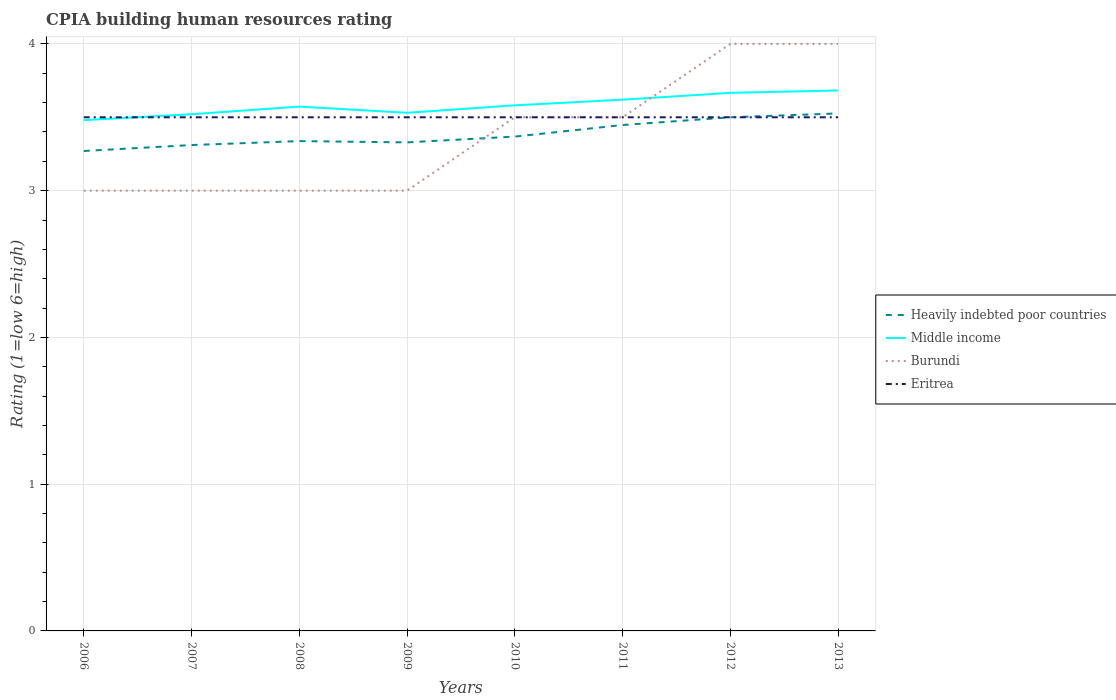In which year was the CPIA rating in Middle income maximum?
Offer a terse response. 2006. What is the difference between two consecutive major ticks on the Y-axis?
Give a very brief answer. 1. Are the values on the major ticks of Y-axis written in scientific E-notation?
Make the answer very short. No. How many legend labels are there?
Give a very brief answer. 4. How are the legend labels stacked?
Ensure brevity in your answer.  Vertical. What is the title of the graph?
Offer a very short reply. CPIA building human resources rating. Does "Turks and Caicos Islands" appear as one of the legend labels in the graph?
Provide a succinct answer. No. What is the label or title of the X-axis?
Provide a short and direct response. Years. What is the Rating (1=low 6=high) in Heavily indebted poor countries in 2006?
Provide a short and direct response. 3.27. What is the Rating (1=low 6=high) in Middle income in 2006?
Keep it short and to the point. 3.48. What is the Rating (1=low 6=high) in Eritrea in 2006?
Provide a short and direct response. 3.5. What is the Rating (1=low 6=high) in Heavily indebted poor countries in 2007?
Your response must be concise. 3.31. What is the Rating (1=low 6=high) of Middle income in 2007?
Provide a short and direct response. 3.52. What is the Rating (1=low 6=high) in Eritrea in 2007?
Provide a succinct answer. 3.5. What is the Rating (1=low 6=high) of Heavily indebted poor countries in 2008?
Keep it short and to the point. 3.34. What is the Rating (1=low 6=high) of Middle income in 2008?
Your response must be concise. 3.57. What is the Rating (1=low 6=high) in Eritrea in 2008?
Make the answer very short. 3.5. What is the Rating (1=low 6=high) in Heavily indebted poor countries in 2009?
Give a very brief answer. 3.33. What is the Rating (1=low 6=high) of Middle income in 2009?
Your answer should be very brief. 3.53. What is the Rating (1=low 6=high) of Eritrea in 2009?
Ensure brevity in your answer.  3.5. What is the Rating (1=low 6=high) of Heavily indebted poor countries in 2010?
Make the answer very short. 3.37. What is the Rating (1=low 6=high) in Middle income in 2010?
Offer a terse response. 3.58. What is the Rating (1=low 6=high) in Heavily indebted poor countries in 2011?
Provide a succinct answer. 3.45. What is the Rating (1=low 6=high) of Middle income in 2011?
Give a very brief answer. 3.62. What is the Rating (1=low 6=high) of Burundi in 2011?
Offer a terse response. 3.5. What is the Rating (1=low 6=high) of Eritrea in 2011?
Your response must be concise. 3.5. What is the Rating (1=low 6=high) of Heavily indebted poor countries in 2012?
Your response must be concise. 3.5. What is the Rating (1=low 6=high) in Middle income in 2012?
Provide a short and direct response. 3.67. What is the Rating (1=low 6=high) in Burundi in 2012?
Provide a succinct answer. 4. What is the Rating (1=low 6=high) in Eritrea in 2012?
Keep it short and to the point. 3.5. What is the Rating (1=low 6=high) in Heavily indebted poor countries in 2013?
Give a very brief answer. 3.53. What is the Rating (1=low 6=high) in Middle income in 2013?
Offer a terse response. 3.68. What is the Rating (1=low 6=high) of Burundi in 2013?
Provide a short and direct response. 4. Across all years, what is the maximum Rating (1=low 6=high) of Heavily indebted poor countries?
Your answer should be compact. 3.53. Across all years, what is the maximum Rating (1=low 6=high) of Middle income?
Your response must be concise. 3.68. Across all years, what is the maximum Rating (1=low 6=high) of Eritrea?
Provide a short and direct response. 3.5. Across all years, what is the minimum Rating (1=low 6=high) in Heavily indebted poor countries?
Offer a terse response. 3.27. Across all years, what is the minimum Rating (1=low 6=high) of Middle income?
Give a very brief answer. 3.48. Across all years, what is the minimum Rating (1=low 6=high) in Burundi?
Provide a succinct answer. 3. Across all years, what is the minimum Rating (1=low 6=high) in Eritrea?
Make the answer very short. 3.5. What is the total Rating (1=low 6=high) of Heavily indebted poor countries in the graph?
Ensure brevity in your answer.  27.09. What is the total Rating (1=low 6=high) in Middle income in the graph?
Keep it short and to the point. 28.66. What is the difference between the Rating (1=low 6=high) in Heavily indebted poor countries in 2006 and that in 2007?
Provide a short and direct response. -0.04. What is the difference between the Rating (1=low 6=high) of Middle income in 2006 and that in 2007?
Offer a very short reply. -0.04. What is the difference between the Rating (1=low 6=high) of Eritrea in 2006 and that in 2007?
Keep it short and to the point. 0. What is the difference between the Rating (1=low 6=high) in Heavily indebted poor countries in 2006 and that in 2008?
Your answer should be compact. -0.07. What is the difference between the Rating (1=low 6=high) of Middle income in 2006 and that in 2008?
Your answer should be very brief. -0.09. What is the difference between the Rating (1=low 6=high) of Heavily indebted poor countries in 2006 and that in 2009?
Offer a terse response. -0.06. What is the difference between the Rating (1=low 6=high) in Middle income in 2006 and that in 2009?
Ensure brevity in your answer.  -0.05. What is the difference between the Rating (1=low 6=high) in Eritrea in 2006 and that in 2009?
Make the answer very short. 0. What is the difference between the Rating (1=low 6=high) of Heavily indebted poor countries in 2006 and that in 2010?
Your response must be concise. -0.1. What is the difference between the Rating (1=low 6=high) in Middle income in 2006 and that in 2010?
Your response must be concise. -0.1. What is the difference between the Rating (1=low 6=high) of Burundi in 2006 and that in 2010?
Your response must be concise. -0.5. What is the difference between the Rating (1=low 6=high) of Eritrea in 2006 and that in 2010?
Your answer should be compact. 0. What is the difference between the Rating (1=low 6=high) of Heavily indebted poor countries in 2006 and that in 2011?
Offer a very short reply. -0.18. What is the difference between the Rating (1=low 6=high) of Middle income in 2006 and that in 2011?
Your response must be concise. -0.14. What is the difference between the Rating (1=low 6=high) in Eritrea in 2006 and that in 2011?
Your answer should be very brief. 0. What is the difference between the Rating (1=low 6=high) in Heavily indebted poor countries in 2006 and that in 2012?
Ensure brevity in your answer.  -0.23. What is the difference between the Rating (1=low 6=high) in Middle income in 2006 and that in 2012?
Ensure brevity in your answer.  -0.19. What is the difference between the Rating (1=low 6=high) of Heavily indebted poor countries in 2006 and that in 2013?
Offer a very short reply. -0.26. What is the difference between the Rating (1=low 6=high) of Middle income in 2006 and that in 2013?
Make the answer very short. -0.2. What is the difference between the Rating (1=low 6=high) in Burundi in 2006 and that in 2013?
Your answer should be very brief. -1. What is the difference between the Rating (1=low 6=high) of Heavily indebted poor countries in 2007 and that in 2008?
Offer a very short reply. -0.03. What is the difference between the Rating (1=low 6=high) of Middle income in 2007 and that in 2008?
Your answer should be very brief. -0.05. What is the difference between the Rating (1=low 6=high) in Eritrea in 2007 and that in 2008?
Give a very brief answer. 0. What is the difference between the Rating (1=low 6=high) of Heavily indebted poor countries in 2007 and that in 2009?
Offer a very short reply. -0.02. What is the difference between the Rating (1=low 6=high) of Middle income in 2007 and that in 2009?
Make the answer very short. -0.01. What is the difference between the Rating (1=low 6=high) in Heavily indebted poor countries in 2007 and that in 2010?
Your answer should be very brief. -0.06. What is the difference between the Rating (1=low 6=high) in Middle income in 2007 and that in 2010?
Give a very brief answer. -0.06. What is the difference between the Rating (1=low 6=high) of Heavily indebted poor countries in 2007 and that in 2011?
Ensure brevity in your answer.  -0.14. What is the difference between the Rating (1=low 6=high) of Middle income in 2007 and that in 2011?
Ensure brevity in your answer.  -0.1. What is the difference between the Rating (1=low 6=high) in Burundi in 2007 and that in 2011?
Keep it short and to the point. -0.5. What is the difference between the Rating (1=low 6=high) in Eritrea in 2007 and that in 2011?
Provide a short and direct response. 0. What is the difference between the Rating (1=low 6=high) in Heavily indebted poor countries in 2007 and that in 2012?
Provide a succinct answer. -0.19. What is the difference between the Rating (1=low 6=high) in Middle income in 2007 and that in 2012?
Give a very brief answer. -0.15. What is the difference between the Rating (1=low 6=high) of Heavily indebted poor countries in 2007 and that in 2013?
Ensure brevity in your answer.  -0.22. What is the difference between the Rating (1=low 6=high) of Middle income in 2007 and that in 2013?
Your answer should be very brief. -0.16. What is the difference between the Rating (1=low 6=high) of Heavily indebted poor countries in 2008 and that in 2009?
Give a very brief answer. 0.01. What is the difference between the Rating (1=low 6=high) in Middle income in 2008 and that in 2009?
Offer a very short reply. 0.04. What is the difference between the Rating (1=low 6=high) of Burundi in 2008 and that in 2009?
Offer a terse response. 0. What is the difference between the Rating (1=low 6=high) in Eritrea in 2008 and that in 2009?
Keep it short and to the point. 0. What is the difference between the Rating (1=low 6=high) in Heavily indebted poor countries in 2008 and that in 2010?
Your response must be concise. -0.03. What is the difference between the Rating (1=low 6=high) in Middle income in 2008 and that in 2010?
Provide a succinct answer. -0.01. What is the difference between the Rating (1=low 6=high) of Burundi in 2008 and that in 2010?
Provide a succinct answer. -0.5. What is the difference between the Rating (1=low 6=high) of Eritrea in 2008 and that in 2010?
Keep it short and to the point. 0. What is the difference between the Rating (1=low 6=high) of Heavily indebted poor countries in 2008 and that in 2011?
Your response must be concise. -0.11. What is the difference between the Rating (1=low 6=high) in Middle income in 2008 and that in 2011?
Provide a short and direct response. -0.05. What is the difference between the Rating (1=low 6=high) of Burundi in 2008 and that in 2011?
Offer a terse response. -0.5. What is the difference between the Rating (1=low 6=high) of Heavily indebted poor countries in 2008 and that in 2012?
Offer a very short reply. -0.16. What is the difference between the Rating (1=low 6=high) of Middle income in 2008 and that in 2012?
Keep it short and to the point. -0.09. What is the difference between the Rating (1=low 6=high) of Burundi in 2008 and that in 2012?
Make the answer very short. -1. What is the difference between the Rating (1=low 6=high) of Heavily indebted poor countries in 2008 and that in 2013?
Give a very brief answer. -0.19. What is the difference between the Rating (1=low 6=high) of Middle income in 2008 and that in 2013?
Make the answer very short. -0.11. What is the difference between the Rating (1=low 6=high) of Eritrea in 2008 and that in 2013?
Give a very brief answer. 0. What is the difference between the Rating (1=low 6=high) in Heavily indebted poor countries in 2009 and that in 2010?
Keep it short and to the point. -0.04. What is the difference between the Rating (1=low 6=high) in Middle income in 2009 and that in 2010?
Provide a short and direct response. -0.05. What is the difference between the Rating (1=low 6=high) of Eritrea in 2009 and that in 2010?
Provide a short and direct response. 0. What is the difference between the Rating (1=low 6=high) of Heavily indebted poor countries in 2009 and that in 2011?
Give a very brief answer. -0.12. What is the difference between the Rating (1=low 6=high) in Middle income in 2009 and that in 2011?
Keep it short and to the point. -0.09. What is the difference between the Rating (1=low 6=high) in Burundi in 2009 and that in 2011?
Your response must be concise. -0.5. What is the difference between the Rating (1=low 6=high) of Eritrea in 2009 and that in 2011?
Your answer should be compact. 0. What is the difference between the Rating (1=low 6=high) of Heavily indebted poor countries in 2009 and that in 2012?
Your answer should be compact. -0.17. What is the difference between the Rating (1=low 6=high) of Middle income in 2009 and that in 2012?
Your answer should be compact. -0.14. What is the difference between the Rating (1=low 6=high) in Burundi in 2009 and that in 2012?
Your response must be concise. -1. What is the difference between the Rating (1=low 6=high) in Heavily indebted poor countries in 2009 and that in 2013?
Your answer should be very brief. -0.2. What is the difference between the Rating (1=low 6=high) in Middle income in 2009 and that in 2013?
Make the answer very short. -0.15. What is the difference between the Rating (1=low 6=high) of Burundi in 2009 and that in 2013?
Make the answer very short. -1. What is the difference between the Rating (1=low 6=high) of Eritrea in 2009 and that in 2013?
Make the answer very short. 0. What is the difference between the Rating (1=low 6=high) in Heavily indebted poor countries in 2010 and that in 2011?
Your answer should be compact. -0.08. What is the difference between the Rating (1=low 6=high) in Middle income in 2010 and that in 2011?
Offer a very short reply. -0.04. What is the difference between the Rating (1=low 6=high) in Burundi in 2010 and that in 2011?
Keep it short and to the point. 0. What is the difference between the Rating (1=low 6=high) in Heavily indebted poor countries in 2010 and that in 2012?
Your answer should be compact. -0.13. What is the difference between the Rating (1=low 6=high) in Middle income in 2010 and that in 2012?
Your answer should be very brief. -0.09. What is the difference between the Rating (1=low 6=high) of Burundi in 2010 and that in 2012?
Your response must be concise. -0.5. What is the difference between the Rating (1=low 6=high) in Heavily indebted poor countries in 2010 and that in 2013?
Make the answer very short. -0.16. What is the difference between the Rating (1=low 6=high) of Middle income in 2010 and that in 2013?
Offer a terse response. -0.1. What is the difference between the Rating (1=low 6=high) in Burundi in 2010 and that in 2013?
Offer a very short reply. -0.5. What is the difference between the Rating (1=low 6=high) of Heavily indebted poor countries in 2011 and that in 2012?
Give a very brief answer. -0.05. What is the difference between the Rating (1=low 6=high) in Middle income in 2011 and that in 2012?
Your answer should be very brief. -0.05. What is the difference between the Rating (1=low 6=high) in Burundi in 2011 and that in 2012?
Make the answer very short. -0.5. What is the difference between the Rating (1=low 6=high) in Eritrea in 2011 and that in 2012?
Offer a very short reply. 0. What is the difference between the Rating (1=low 6=high) in Heavily indebted poor countries in 2011 and that in 2013?
Provide a short and direct response. -0.08. What is the difference between the Rating (1=low 6=high) in Middle income in 2011 and that in 2013?
Give a very brief answer. -0.06. What is the difference between the Rating (1=low 6=high) of Burundi in 2011 and that in 2013?
Offer a very short reply. -0.5. What is the difference between the Rating (1=low 6=high) in Eritrea in 2011 and that in 2013?
Ensure brevity in your answer.  0. What is the difference between the Rating (1=low 6=high) in Heavily indebted poor countries in 2012 and that in 2013?
Your response must be concise. -0.03. What is the difference between the Rating (1=low 6=high) in Middle income in 2012 and that in 2013?
Ensure brevity in your answer.  -0.02. What is the difference between the Rating (1=low 6=high) in Burundi in 2012 and that in 2013?
Your answer should be compact. 0. What is the difference between the Rating (1=low 6=high) in Eritrea in 2012 and that in 2013?
Offer a very short reply. 0. What is the difference between the Rating (1=low 6=high) in Heavily indebted poor countries in 2006 and the Rating (1=low 6=high) in Middle income in 2007?
Keep it short and to the point. -0.25. What is the difference between the Rating (1=low 6=high) of Heavily indebted poor countries in 2006 and the Rating (1=low 6=high) of Burundi in 2007?
Make the answer very short. 0.27. What is the difference between the Rating (1=low 6=high) of Heavily indebted poor countries in 2006 and the Rating (1=low 6=high) of Eritrea in 2007?
Your response must be concise. -0.23. What is the difference between the Rating (1=low 6=high) of Middle income in 2006 and the Rating (1=low 6=high) of Burundi in 2007?
Your response must be concise. 0.48. What is the difference between the Rating (1=low 6=high) of Middle income in 2006 and the Rating (1=low 6=high) of Eritrea in 2007?
Your answer should be compact. -0.02. What is the difference between the Rating (1=low 6=high) in Heavily indebted poor countries in 2006 and the Rating (1=low 6=high) in Middle income in 2008?
Provide a succinct answer. -0.3. What is the difference between the Rating (1=low 6=high) in Heavily indebted poor countries in 2006 and the Rating (1=low 6=high) in Burundi in 2008?
Ensure brevity in your answer.  0.27. What is the difference between the Rating (1=low 6=high) of Heavily indebted poor countries in 2006 and the Rating (1=low 6=high) of Eritrea in 2008?
Your response must be concise. -0.23. What is the difference between the Rating (1=low 6=high) in Middle income in 2006 and the Rating (1=low 6=high) in Burundi in 2008?
Provide a succinct answer. 0.48. What is the difference between the Rating (1=low 6=high) of Middle income in 2006 and the Rating (1=low 6=high) of Eritrea in 2008?
Your response must be concise. -0.02. What is the difference between the Rating (1=low 6=high) of Heavily indebted poor countries in 2006 and the Rating (1=low 6=high) of Middle income in 2009?
Make the answer very short. -0.26. What is the difference between the Rating (1=low 6=high) in Heavily indebted poor countries in 2006 and the Rating (1=low 6=high) in Burundi in 2009?
Give a very brief answer. 0.27. What is the difference between the Rating (1=low 6=high) in Heavily indebted poor countries in 2006 and the Rating (1=low 6=high) in Eritrea in 2009?
Make the answer very short. -0.23. What is the difference between the Rating (1=low 6=high) of Middle income in 2006 and the Rating (1=low 6=high) of Burundi in 2009?
Make the answer very short. 0.48. What is the difference between the Rating (1=low 6=high) of Middle income in 2006 and the Rating (1=low 6=high) of Eritrea in 2009?
Your answer should be compact. -0.02. What is the difference between the Rating (1=low 6=high) in Burundi in 2006 and the Rating (1=low 6=high) in Eritrea in 2009?
Offer a terse response. -0.5. What is the difference between the Rating (1=low 6=high) of Heavily indebted poor countries in 2006 and the Rating (1=low 6=high) of Middle income in 2010?
Your response must be concise. -0.31. What is the difference between the Rating (1=low 6=high) in Heavily indebted poor countries in 2006 and the Rating (1=low 6=high) in Burundi in 2010?
Offer a terse response. -0.23. What is the difference between the Rating (1=low 6=high) of Heavily indebted poor countries in 2006 and the Rating (1=low 6=high) of Eritrea in 2010?
Ensure brevity in your answer.  -0.23. What is the difference between the Rating (1=low 6=high) of Middle income in 2006 and the Rating (1=low 6=high) of Burundi in 2010?
Make the answer very short. -0.02. What is the difference between the Rating (1=low 6=high) of Middle income in 2006 and the Rating (1=low 6=high) of Eritrea in 2010?
Keep it short and to the point. -0.02. What is the difference between the Rating (1=low 6=high) of Burundi in 2006 and the Rating (1=low 6=high) of Eritrea in 2010?
Keep it short and to the point. -0.5. What is the difference between the Rating (1=low 6=high) in Heavily indebted poor countries in 2006 and the Rating (1=low 6=high) in Middle income in 2011?
Your answer should be very brief. -0.35. What is the difference between the Rating (1=low 6=high) of Heavily indebted poor countries in 2006 and the Rating (1=low 6=high) of Burundi in 2011?
Your answer should be very brief. -0.23. What is the difference between the Rating (1=low 6=high) in Heavily indebted poor countries in 2006 and the Rating (1=low 6=high) in Eritrea in 2011?
Keep it short and to the point. -0.23. What is the difference between the Rating (1=low 6=high) in Middle income in 2006 and the Rating (1=low 6=high) in Burundi in 2011?
Provide a succinct answer. -0.02. What is the difference between the Rating (1=low 6=high) of Middle income in 2006 and the Rating (1=low 6=high) of Eritrea in 2011?
Offer a terse response. -0.02. What is the difference between the Rating (1=low 6=high) in Burundi in 2006 and the Rating (1=low 6=high) in Eritrea in 2011?
Provide a succinct answer. -0.5. What is the difference between the Rating (1=low 6=high) in Heavily indebted poor countries in 2006 and the Rating (1=low 6=high) in Middle income in 2012?
Your answer should be compact. -0.4. What is the difference between the Rating (1=low 6=high) of Heavily indebted poor countries in 2006 and the Rating (1=low 6=high) of Burundi in 2012?
Your response must be concise. -0.73. What is the difference between the Rating (1=low 6=high) in Heavily indebted poor countries in 2006 and the Rating (1=low 6=high) in Eritrea in 2012?
Your answer should be very brief. -0.23. What is the difference between the Rating (1=low 6=high) in Middle income in 2006 and the Rating (1=low 6=high) in Burundi in 2012?
Your answer should be very brief. -0.52. What is the difference between the Rating (1=low 6=high) of Middle income in 2006 and the Rating (1=low 6=high) of Eritrea in 2012?
Provide a short and direct response. -0.02. What is the difference between the Rating (1=low 6=high) of Heavily indebted poor countries in 2006 and the Rating (1=low 6=high) of Middle income in 2013?
Keep it short and to the point. -0.41. What is the difference between the Rating (1=low 6=high) in Heavily indebted poor countries in 2006 and the Rating (1=low 6=high) in Burundi in 2013?
Give a very brief answer. -0.73. What is the difference between the Rating (1=low 6=high) in Heavily indebted poor countries in 2006 and the Rating (1=low 6=high) in Eritrea in 2013?
Your response must be concise. -0.23. What is the difference between the Rating (1=low 6=high) in Middle income in 2006 and the Rating (1=low 6=high) in Burundi in 2013?
Ensure brevity in your answer.  -0.52. What is the difference between the Rating (1=low 6=high) of Middle income in 2006 and the Rating (1=low 6=high) of Eritrea in 2013?
Your response must be concise. -0.02. What is the difference between the Rating (1=low 6=high) of Heavily indebted poor countries in 2007 and the Rating (1=low 6=high) of Middle income in 2008?
Provide a succinct answer. -0.26. What is the difference between the Rating (1=low 6=high) of Heavily indebted poor countries in 2007 and the Rating (1=low 6=high) of Burundi in 2008?
Offer a very short reply. 0.31. What is the difference between the Rating (1=low 6=high) of Heavily indebted poor countries in 2007 and the Rating (1=low 6=high) of Eritrea in 2008?
Provide a succinct answer. -0.19. What is the difference between the Rating (1=low 6=high) of Middle income in 2007 and the Rating (1=low 6=high) of Burundi in 2008?
Offer a very short reply. 0.52. What is the difference between the Rating (1=low 6=high) in Middle income in 2007 and the Rating (1=low 6=high) in Eritrea in 2008?
Provide a succinct answer. 0.02. What is the difference between the Rating (1=low 6=high) of Heavily indebted poor countries in 2007 and the Rating (1=low 6=high) of Middle income in 2009?
Offer a very short reply. -0.22. What is the difference between the Rating (1=low 6=high) in Heavily indebted poor countries in 2007 and the Rating (1=low 6=high) in Burundi in 2009?
Your response must be concise. 0.31. What is the difference between the Rating (1=low 6=high) of Heavily indebted poor countries in 2007 and the Rating (1=low 6=high) of Eritrea in 2009?
Offer a terse response. -0.19. What is the difference between the Rating (1=low 6=high) of Middle income in 2007 and the Rating (1=low 6=high) of Burundi in 2009?
Give a very brief answer. 0.52. What is the difference between the Rating (1=low 6=high) in Middle income in 2007 and the Rating (1=low 6=high) in Eritrea in 2009?
Keep it short and to the point. 0.02. What is the difference between the Rating (1=low 6=high) of Heavily indebted poor countries in 2007 and the Rating (1=low 6=high) of Middle income in 2010?
Ensure brevity in your answer.  -0.27. What is the difference between the Rating (1=low 6=high) of Heavily indebted poor countries in 2007 and the Rating (1=low 6=high) of Burundi in 2010?
Offer a very short reply. -0.19. What is the difference between the Rating (1=low 6=high) of Heavily indebted poor countries in 2007 and the Rating (1=low 6=high) of Eritrea in 2010?
Make the answer very short. -0.19. What is the difference between the Rating (1=low 6=high) of Middle income in 2007 and the Rating (1=low 6=high) of Burundi in 2010?
Give a very brief answer. 0.02. What is the difference between the Rating (1=low 6=high) in Middle income in 2007 and the Rating (1=low 6=high) in Eritrea in 2010?
Offer a very short reply. 0.02. What is the difference between the Rating (1=low 6=high) in Heavily indebted poor countries in 2007 and the Rating (1=low 6=high) in Middle income in 2011?
Your response must be concise. -0.31. What is the difference between the Rating (1=low 6=high) in Heavily indebted poor countries in 2007 and the Rating (1=low 6=high) in Burundi in 2011?
Provide a succinct answer. -0.19. What is the difference between the Rating (1=low 6=high) in Heavily indebted poor countries in 2007 and the Rating (1=low 6=high) in Eritrea in 2011?
Your answer should be very brief. -0.19. What is the difference between the Rating (1=low 6=high) of Middle income in 2007 and the Rating (1=low 6=high) of Burundi in 2011?
Provide a short and direct response. 0.02. What is the difference between the Rating (1=low 6=high) in Middle income in 2007 and the Rating (1=low 6=high) in Eritrea in 2011?
Keep it short and to the point. 0.02. What is the difference between the Rating (1=low 6=high) in Heavily indebted poor countries in 2007 and the Rating (1=low 6=high) in Middle income in 2012?
Your answer should be compact. -0.36. What is the difference between the Rating (1=low 6=high) in Heavily indebted poor countries in 2007 and the Rating (1=low 6=high) in Burundi in 2012?
Your answer should be very brief. -0.69. What is the difference between the Rating (1=low 6=high) of Heavily indebted poor countries in 2007 and the Rating (1=low 6=high) of Eritrea in 2012?
Make the answer very short. -0.19. What is the difference between the Rating (1=low 6=high) in Middle income in 2007 and the Rating (1=low 6=high) in Burundi in 2012?
Your answer should be very brief. -0.48. What is the difference between the Rating (1=low 6=high) in Middle income in 2007 and the Rating (1=low 6=high) in Eritrea in 2012?
Give a very brief answer. 0.02. What is the difference between the Rating (1=low 6=high) of Burundi in 2007 and the Rating (1=low 6=high) of Eritrea in 2012?
Your answer should be very brief. -0.5. What is the difference between the Rating (1=low 6=high) in Heavily indebted poor countries in 2007 and the Rating (1=low 6=high) in Middle income in 2013?
Give a very brief answer. -0.37. What is the difference between the Rating (1=low 6=high) in Heavily indebted poor countries in 2007 and the Rating (1=low 6=high) in Burundi in 2013?
Provide a succinct answer. -0.69. What is the difference between the Rating (1=low 6=high) of Heavily indebted poor countries in 2007 and the Rating (1=low 6=high) of Eritrea in 2013?
Keep it short and to the point. -0.19. What is the difference between the Rating (1=low 6=high) of Middle income in 2007 and the Rating (1=low 6=high) of Burundi in 2013?
Ensure brevity in your answer.  -0.48. What is the difference between the Rating (1=low 6=high) in Middle income in 2007 and the Rating (1=low 6=high) in Eritrea in 2013?
Offer a very short reply. 0.02. What is the difference between the Rating (1=low 6=high) in Heavily indebted poor countries in 2008 and the Rating (1=low 6=high) in Middle income in 2009?
Ensure brevity in your answer.  -0.19. What is the difference between the Rating (1=low 6=high) of Heavily indebted poor countries in 2008 and the Rating (1=low 6=high) of Burundi in 2009?
Keep it short and to the point. 0.34. What is the difference between the Rating (1=low 6=high) in Heavily indebted poor countries in 2008 and the Rating (1=low 6=high) in Eritrea in 2009?
Keep it short and to the point. -0.16. What is the difference between the Rating (1=low 6=high) in Middle income in 2008 and the Rating (1=low 6=high) in Burundi in 2009?
Offer a very short reply. 0.57. What is the difference between the Rating (1=low 6=high) in Middle income in 2008 and the Rating (1=low 6=high) in Eritrea in 2009?
Offer a very short reply. 0.07. What is the difference between the Rating (1=low 6=high) of Burundi in 2008 and the Rating (1=low 6=high) of Eritrea in 2009?
Provide a short and direct response. -0.5. What is the difference between the Rating (1=low 6=high) in Heavily indebted poor countries in 2008 and the Rating (1=low 6=high) in Middle income in 2010?
Make the answer very short. -0.24. What is the difference between the Rating (1=low 6=high) of Heavily indebted poor countries in 2008 and the Rating (1=low 6=high) of Burundi in 2010?
Your response must be concise. -0.16. What is the difference between the Rating (1=low 6=high) of Heavily indebted poor countries in 2008 and the Rating (1=low 6=high) of Eritrea in 2010?
Offer a very short reply. -0.16. What is the difference between the Rating (1=low 6=high) in Middle income in 2008 and the Rating (1=low 6=high) in Burundi in 2010?
Ensure brevity in your answer.  0.07. What is the difference between the Rating (1=low 6=high) of Middle income in 2008 and the Rating (1=low 6=high) of Eritrea in 2010?
Ensure brevity in your answer.  0.07. What is the difference between the Rating (1=low 6=high) of Heavily indebted poor countries in 2008 and the Rating (1=low 6=high) of Middle income in 2011?
Your answer should be compact. -0.28. What is the difference between the Rating (1=low 6=high) of Heavily indebted poor countries in 2008 and the Rating (1=low 6=high) of Burundi in 2011?
Offer a terse response. -0.16. What is the difference between the Rating (1=low 6=high) in Heavily indebted poor countries in 2008 and the Rating (1=low 6=high) in Eritrea in 2011?
Ensure brevity in your answer.  -0.16. What is the difference between the Rating (1=low 6=high) of Middle income in 2008 and the Rating (1=low 6=high) of Burundi in 2011?
Offer a terse response. 0.07. What is the difference between the Rating (1=low 6=high) in Middle income in 2008 and the Rating (1=low 6=high) in Eritrea in 2011?
Make the answer very short. 0.07. What is the difference between the Rating (1=low 6=high) in Heavily indebted poor countries in 2008 and the Rating (1=low 6=high) in Middle income in 2012?
Offer a terse response. -0.33. What is the difference between the Rating (1=low 6=high) in Heavily indebted poor countries in 2008 and the Rating (1=low 6=high) in Burundi in 2012?
Your answer should be very brief. -0.66. What is the difference between the Rating (1=low 6=high) in Heavily indebted poor countries in 2008 and the Rating (1=low 6=high) in Eritrea in 2012?
Give a very brief answer. -0.16. What is the difference between the Rating (1=low 6=high) of Middle income in 2008 and the Rating (1=low 6=high) of Burundi in 2012?
Make the answer very short. -0.43. What is the difference between the Rating (1=low 6=high) of Middle income in 2008 and the Rating (1=low 6=high) of Eritrea in 2012?
Offer a terse response. 0.07. What is the difference between the Rating (1=low 6=high) of Heavily indebted poor countries in 2008 and the Rating (1=low 6=high) of Middle income in 2013?
Ensure brevity in your answer.  -0.34. What is the difference between the Rating (1=low 6=high) in Heavily indebted poor countries in 2008 and the Rating (1=low 6=high) in Burundi in 2013?
Offer a terse response. -0.66. What is the difference between the Rating (1=low 6=high) of Heavily indebted poor countries in 2008 and the Rating (1=low 6=high) of Eritrea in 2013?
Offer a very short reply. -0.16. What is the difference between the Rating (1=low 6=high) in Middle income in 2008 and the Rating (1=low 6=high) in Burundi in 2013?
Your answer should be very brief. -0.43. What is the difference between the Rating (1=low 6=high) of Middle income in 2008 and the Rating (1=low 6=high) of Eritrea in 2013?
Your response must be concise. 0.07. What is the difference between the Rating (1=low 6=high) of Heavily indebted poor countries in 2009 and the Rating (1=low 6=high) of Middle income in 2010?
Your answer should be compact. -0.25. What is the difference between the Rating (1=low 6=high) of Heavily indebted poor countries in 2009 and the Rating (1=low 6=high) of Burundi in 2010?
Keep it short and to the point. -0.17. What is the difference between the Rating (1=low 6=high) in Heavily indebted poor countries in 2009 and the Rating (1=low 6=high) in Eritrea in 2010?
Keep it short and to the point. -0.17. What is the difference between the Rating (1=low 6=high) in Middle income in 2009 and the Rating (1=low 6=high) in Burundi in 2010?
Offer a very short reply. 0.03. What is the difference between the Rating (1=low 6=high) in Middle income in 2009 and the Rating (1=low 6=high) in Eritrea in 2010?
Keep it short and to the point. 0.03. What is the difference between the Rating (1=low 6=high) in Burundi in 2009 and the Rating (1=low 6=high) in Eritrea in 2010?
Give a very brief answer. -0.5. What is the difference between the Rating (1=low 6=high) of Heavily indebted poor countries in 2009 and the Rating (1=low 6=high) of Middle income in 2011?
Your answer should be compact. -0.29. What is the difference between the Rating (1=low 6=high) of Heavily indebted poor countries in 2009 and the Rating (1=low 6=high) of Burundi in 2011?
Keep it short and to the point. -0.17. What is the difference between the Rating (1=low 6=high) of Heavily indebted poor countries in 2009 and the Rating (1=low 6=high) of Eritrea in 2011?
Your response must be concise. -0.17. What is the difference between the Rating (1=low 6=high) in Middle income in 2009 and the Rating (1=low 6=high) in Burundi in 2011?
Offer a terse response. 0.03. What is the difference between the Rating (1=low 6=high) of Middle income in 2009 and the Rating (1=low 6=high) of Eritrea in 2011?
Offer a terse response. 0.03. What is the difference between the Rating (1=low 6=high) of Heavily indebted poor countries in 2009 and the Rating (1=low 6=high) of Middle income in 2012?
Provide a succinct answer. -0.34. What is the difference between the Rating (1=low 6=high) in Heavily indebted poor countries in 2009 and the Rating (1=low 6=high) in Burundi in 2012?
Make the answer very short. -0.67. What is the difference between the Rating (1=low 6=high) in Heavily indebted poor countries in 2009 and the Rating (1=low 6=high) in Eritrea in 2012?
Make the answer very short. -0.17. What is the difference between the Rating (1=low 6=high) of Middle income in 2009 and the Rating (1=low 6=high) of Burundi in 2012?
Offer a terse response. -0.47. What is the difference between the Rating (1=low 6=high) in Middle income in 2009 and the Rating (1=low 6=high) in Eritrea in 2012?
Provide a short and direct response. 0.03. What is the difference between the Rating (1=low 6=high) in Heavily indebted poor countries in 2009 and the Rating (1=low 6=high) in Middle income in 2013?
Your answer should be very brief. -0.35. What is the difference between the Rating (1=low 6=high) of Heavily indebted poor countries in 2009 and the Rating (1=low 6=high) of Burundi in 2013?
Provide a succinct answer. -0.67. What is the difference between the Rating (1=low 6=high) of Heavily indebted poor countries in 2009 and the Rating (1=low 6=high) of Eritrea in 2013?
Offer a very short reply. -0.17. What is the difference between the Rating (1=low 6=high) in Middle income in 2009 and the Rating (1=low 6=high) in Burundi in 2013?
Make the answer very short. -0.47. What is the difference between the Rating (1=low 6=high) in Middle income in 2009 and the Rating (1=low 6=high) in Eritrea in 2013?
Your response must be concise. 0.03. What is the difference between the Rating (1=low 6=high) in Heavily indebted poor countries in 2010 and the Rating (1=low 6=high) in Middle income in 2011?
Your response must be concise. -0.25. What is the difference between the Rating (1=low 6=high) in Heavily indebted poor countries in 2010 and the Rating (1=low 6=high) in Burundi in 2011?
Ensure brevity in your answer.  -0.13. What is the difference between the Rating (1=low 6=high) in Heavily indebted poor countries in 2010 and the Rating (1=low 6=high) in Eritrea in 2011?
Provide a short and direct response. -0.13. What is the difference between the Rating (1=low 6=high) in Middle income in 2010 and the Rating (1=low 6=high) in Burundi in 2011?
Provide a succinct answer. 0.08. What is the difference between the Rating (1=low 6=high) in Middle income in 2010 and the Rating (1=low 6=high) in Eritrea in 2011?
Offer a terse response. 0.08. What is the difference between the Rating (1=low 6=high) in Heavily indebted poor countries in 2010 and the Rating (1=low 6=high) in Middle income in 2012?
Your answer should be very brief. -0.3. What is the difference between the Rating (1=low 6=high) of Heavily indebted poor countries in 2010 and the Rating (1=low 6=high) of Burundi in 2012?
Keep it short and to the point. -0.63. What is the difference between the Rating (1=low 6=high) of Heavily indebted poor countries in 2010 and the Rating (1=low 6=high) of Eritrea in 2012?
Provide a short and direct response. -0.13. What is the difference between the Rating (1=low 6=high) of Middle income in 2010 and the Rating (1=low 6=high) of Burundi in 2012?
Make the answer very short. -0.42. What is the difference between the Rating (1=low 6=high) in Middle income in 2010 and the Rating (1=low 6=high) in Eritrea in 2012?
Offer a very short reply. 0.08. What is the difference between the Rating (1=low 6=high) of Burundi in 2010 and the Rating (1=low 6=high) of Eritrea in 2012?
Your answer should be very brief. 0. What is the difference between the Rating (1=low 6=high) in Heavily indebted poor countries in 2010 and the Rating (1=low 6=high) in Middle income in 2013?
Your answer should be compact. -0.31. What is the difference between the Rating (1=low 6=high) in Heavily indebted poor countries in 2010 and the Rating (1=low 6=high) in Burundi in 2013?
Provide a short and direct response. -0.63. What is the difference between the Rating (1=low 6=high) in Heavily indebted poor countries in 2010 and the Rating (1=low 6=high) in Eritrea in 2013?
Offer a terse response. -0.13. What is the difference between the Rating (1=low 6=high) in Middle income in 2010 and the Rating (1=low 6=high) in Burundi in 2013?
Provide a short and direct response. -0.42. What is the difference between the Rating (1=low 6=high) in Middle income in 2010 and the Rating (1=low 6=high) in Eritrea in 2013?
Your answer should be very brief. 0.08. What is the difference between the Rating (1=low 6=high) of Burundi in 2010 and the Rating (1=low 6=high) of Eritrea in 2013?
Your answer should be compact. 0. What is the difference between the Rating (1=low 6=high) in Heavily indebted poor countries in 2011 and the Rating (1=low 6=high) in Middle income in 2012?
Your answer should be compact. -0.22. What is the difference between the Rating (1=low 6=high) of Heavily indebted poor countries in 2011 and the Rating (1=low 6=high) of Burundi in 2012?
Your answer should be very brief. -0.55. What is the difference between the Rating (1=low 6=high) of Heavily indebted poor countries in 2011 and the Rating (1=low 6=high) of Eritrea in 2012?
Your answer should be compact. -0.05. What is the difference between the Rating (1=low 6=high) of Middle income in 2011 and the Rating (1=low 6=high) of Burundi in 2012?
Give a very brief answer. -0.38. What is the difference between the Rating (1=low 6=high) of Middle income in 2011 and the Rating (1=low 6=high) of Eritrea in 2012?
Your answer should be compact. 0.12. What is the difference between the Rating (1=low 6=high) in Burundi in 2011 and the Rating (1=low 6=high) in Eritrea in 2012?
Keep it short and to the point. 0. What is the difference between the Rating (1=low 6=high) in Heavily indebted poor countries in 2011 and the Rating (1=low 6=high) in Middle income in 2013?
Your response must be concise. -0.24. What is the difference between the Rating (1=low 6=high) in Heavily indebted poor countries in 2011 and the Rating (1=low 6=high) in Burundi in 2013?
Offer a terse response. -0.55. What is the difference between the Rating (1=low 6=high) of Heavily indebted poor countries in 2011 and the Rating (1=low 6=high) of Eritrea in 2013?
Provide a succinct answer. -0.05. What is the difference between the Rating (1=low 6=high) in Middle income in 2011 and the Rating (1=low 6=high) in Burundi in 2013?
Your response must be concise. -0.38. What is the difference between the Rating (1=low 6=high) in Middle income in 2011 and the Rating (1=low 6=high) in Eritrea in 2013?
Offer a very short reply. 0.12. What is the difference between the Rating (1=low 6=high) of Burundi in 2011 and the Rating (1=low 6=high) of Eritrea in 2013?
Offer a terse response. 0. What is the difference between the Rating (1=low 6=high) in Heavily indebted poor countries in 2012 and the Rating (1=low 6=high) in Middle income in 2013?
Your response must be concise. -0.18. What is the difference between the Rating (1=low 6=high) in Heavily indebted poor countries in 2012 and the Rating (1=low 6=high) in Burundi in 2013?
Provide a short and direct response. -0.5. What is the difference between the Rating (1=low 6=high) of Middle income in 2012 and the Rating (1=low 6=high) of Eritrea in 2013?
Provide a short and direct response. 0.17. What is the difference between the Rating (1=low 6=high) of Burundi in 2012 and the Rating (1=low 6=high) of Eritrea in 2013?
Your response must be concise. 0.5. What is the average Rating (1=low 6=high) of Heavily indebted poor countries per year?
Your answer should be very brief. 3.39. What is the average Rating (1=low 6=high) in Middle income per year?
Give a very brief answer. 3.58. What is the average Rating (1=low 6=high) of Burundi per year?
Give a very brief answer. 3.38. What is the average Rating (1=low 6=high) in Eritrea per year?
Provide a succinct answer. 3.5. In the year 2006, what is the difference between the Rating (1=low 6=high) in Heavily indebted poor countries and Rating (1=low 6=high) in Middle income?
Provide a succinct answer. -0.21. In the year 2006, what is the difference between the Rating (1=low 6=high) of Heavily indebted poor countries and Rating (1=low 6=high) of Burundi?
Provide a short and direct response. 0.27. In the year 2006, what is the difference between the Rating (1=low 6=high) in Heavily indebted poor countries and Rating (1=low 6=high) in Eritrea?
Provide a succinct answer. -0.23. In the year 2006, what is the difference between the Rating (1=low 6=high) in Middle income and Rating (1=low 6=high) in Burundi?
Provide a succinct answer. 0.48. In the year 2006, what is the difference between the Rating (1=low 6=high) in Middle income and Rating (1=low 6=high) in Eritrea?
Provide a succinct answer. -0.02. In the year 2007, what is the difference between the Rating (1=low 6=high) of Heavily indebted poor countries and Rating (1=low 6=high) of Middle income?
Give a very brief answer. -0.21. In the year 2007, what is the difference between the Rating (1=low 6=high) of Heavily indebted poor countries and Rating (1=low 6=high) of Burundi?
Your response must be concise. 0.31. In the year 2007, what is the difference between the Rating (1=low 6=high) of Heavily indebted poor countries and Rating (1=low 6=high) of Eritrea?
Keep it short and to the point. -0.19. In the year 2007, what is the difference between the Rating (1=low 6=high) in Middle income and Rating (1=low 6=high) in Burundi?
Keep it short and to the point. 0.52. In the year 2007, what is the difference between the Rating (1=low 6=high) in Middle income and Rating (1=low 6=high) in Eritrea?
Offer a very short reply. 0.02. In the year 2007, what is the difference between the Rating (1=low 6=high) of Burundi and Rating (1=low 6=high) of Eritrea?
Your answer should be compact. -0.5. In the year 2008, what is the difference between the Rating (1=low 6=high) in Heavily indebted poor countries and Rating (1=low 6=high) in Middle income?
Keep it short and to the point. -0.24. In the year 2008, what is the difference between the Rating (1=low 6=high) of Heavily indebted poor countries and Rating (1=low 6=high) of Burundi?
Your response must be concise. 0.34. In the year 2008, what is the difference between the Rating (1=low 6=high) of Heavily indebted poor countries and Rating (1=low 6=high) of Eritrea?
Ensure brevity in your answer.  -0.16. In the year 2008, what is the difference between the Rating (1=low 6=high) in Middle income and Rating (1=low 6=high) in Burundi?
Provide a succinct answer. 0.57. In the year 2008, what is the difference between the Rating (1=low 6=high) of Middle income and Rating (1=low 6=high) of Eritrea?
Offer a terse response. 0.07. In the year 2008, what is the difference between the Rating (1=low 6=high) of Burundi and Rating (1=low 6=high) of Eritrea?
Provide a short and direct response. -0.5. In the year 2009, what is the difference between the Rating (1=low 6=high) in Heavily indebted poor countries and Rating (1=low 6=high) in Middle income?
Offer a very short reply. -0.2. In the year 2009, what is the difference between the Rating (1=low 6=high) in Heavily indebted poor countries and Rating (1=low 6=high) in Burundi?
Ensure brevity in your answer.  0.33. In the year 2009, what is the difference between the Rating (1=low 6=high) of Heavily indebted poor countries and Rating (1=low 6=high) of Eritrea?
Provide a succinct answer. -0.17. In the year 2009, what is the difference between the Rating (1=low 6=high) in Middle income and Rating (1=low 6=high) in Burundi?
Keep it short and to the point. 0.53. In the year 2009, what is the difference between the Rating (1=low 6=high) of Middle income and Rating (1=low 6=high) of Eritrea?
Your answer should be compact. 0.03. In the year 2009, what is the difference between the Rating (1=low 6=high) of Burundi and Rating (1=low 6=high) of Eritrea?
Ensure brevity in your answer.  -0.5. In the year 2010, what is the difference between the Rating (1=low 6=high) in Heavily indebted poor countries and Rating (1=low 6=high) in Middle income?
Give a very brief answer. -0.21. In the year 2010, what is the difference between the Rating (1=low 6=high) of Heavily indebted poor countries and Rating (1=low 6=high) of Burundi?
Keep it short and to the point. -0.13. In the year 2010, what is the difference between the Rating (1=low 6=high) in Heavily indebted poor countries and Rating (1=low 6=high) in Eritrea?
Provide a short and direct response. -0.13. In the year 2010, what is the difference between the Rating (1=low 6=high) in Middle income and Rating (1=low 6=high) in Burundi?
Offer a very short reply. 0.08. In the year 2010, what is the difference between the Rating (1=low 6=high) in Middle income and Rating (1=low 6=high) in Eritrea?
Your answer should be compact. 0.08. In the year 2010, what is the difference between the Rating (1=low 6=high) in Burundi and Rating (1=low 6=high) in Eritrea?
Make the answer very short. 0. In the year 2011, what is the difference between the Rating (1=low 6=high) in Heavily indebted poor countries and Rating (1=low 6=high) in Middle income?
Offer a very short reply. -0.17. In the year 2011, what is the difference between the Rating (1=low 6=high) in Heavily indebted poor countries and Rating (1=low 6=high) in Burundi?
Keep it short and to the point. -0.05. In the year 2011, what is the difference between the Rating (1=low 6=high) in Heavily indebted poor countries and Rating (1=low 6=high) in Eritrea?
Make the answer very short. -0.05. In the year 2011, what is the difference between the Rating (1=low 6=high) of Middle income and Rating (1=low 6=high) of Burundi?
Ensure brevity in your answer.  0.12. In the year 2011, what is the difference between the Rating (1=low 6=high) of Middle income and Rating (1=low 6=high) of Eritrea?
Your answer should be compact. 0.12. In the year 2011, what is the difference between the Rating (1=low 6=high) of Burundi and Rating (1=low 6=high) of Eritrea?
Provide a succinct answer. 0. In the year 2012, what is the difference between the Rating (1=low 6=high) in Heavily indebted poor countries and Rating (1=low 6=high) in Burundi?
Provide a succinct answer. -0.5. In the year 2013, what is the difference between the Rating (1=low 6=high) of Heavily indebted poor countries and Rating (1=low 6=high) of Middle income?
Give a very brief answer. -0.16. In the year 2013, what is the difference between the Rating (1=low 6=high) of Heavily indebted poor countries and Rating (1=low 6=high) of Burundi?
Give a very brief answer. -0.47. In the year 2013, what is the difference between the Rating (1=low 6=high) of Heavily indebted poor countries and Rating (1=low 6=high) of Eritrea?
Give a very brief answer. 0.03. In the year 2013, what is the difference between the Rating (1=low 6=high) in Middle income and Rating (1=low 6=high) in Burundi?
Your answer should be compact. -0.32. In the year 2013, what is the difference between the Rating (1=low 6=high) of Middle income and Rating (1=low 6=high) of Eritrea?
Provide a succinct answer. 0.18. In the year 2013, what is the difference between the Rating (1=low 6=high) of Burundi and Rating (1=low 6=high) of Eritrea?
Offer a terse response. 0.5. What is the ratio of the Rating (1=low 6=high) of Heavily indebted poor countries in 2006 to that in 2007?
Give a very brief answer. 0.99. What is the ratio of the Rating (1=low 6=high) of Burundi in 2006 to that in 2007?
Your answer should be very brief. 1. What is the ratio of the Rating (1=low 6=high) in Heavily indebted poor countries in 2006 to that in 2008?
Your answer should be very brief. 0.98. What is the ratio of the Rating (1=low 6=high) of Middle income in 2006 to that in 2008?
Your response must be concise. 0.97. What is the ratio of the Rating (1=low 6=high) in Eritrea in 2006 to that in 2008?
Provide a short and direct response. 1. What is the ratio of the Rating (1=low 6=high) of Heavily indebted poor countries in 2006 to that in 2009?
Your answer should be compact. 0.98. What is the ratio of the Rating (1=low 6=high) in Middle income in 2006 to that in 2009?
Keep it short and to the point. 0.99. What is the ratio of the Rating (1=low 6=high) of Burundi in 2006 to that in 2009?
Offer a terse response. 1. What is the ratio of the Rating (1=low 6=high) in Eritrea in 2006 to that in 2009?
Give a very brief answer. 1. What is the ratio of the Rating (1=low 6=high) of Heavily indebted poor countries in 2006 to that in 2010?
Offer a very short reply. 0.97. What is the ratio of the Rating (1=low 6=high) in Middle income in 2006 to that in 2010?
Give a very brief answer. 0.97. What is the ratio of the Rating (1=low 6=high) of Burundi in 2006 to that in 2010?
Give a very brief answer. 0.86. What is the ratio of the Rating (1=low 6=high) in Eritrea in 2006 to that in 2010?
Ensure brevity in your answer.  1. What is the ratio of the Rating (1=low 6=high) of Heavily indebted poor countries in 2006 to that in 2011?
Ensure brevity in your answer.  0.95. What is the ratio of the Rating (1=low 6=high) of Middle income in 2006 to that in 2011?
Your answer should be very brief. 0.96. What is the ratio of the Rating (1=low 6=high) of Heavily indebted poor countries in 2006 to that in 2012?
Give a very brief answer. 0.93. What is the ratio of the Rating (1=low 6=high) in Middle income in 2006 to that in 2012?
Provide a short and direct response. 0.95. What is the ratio of the Rating (1=low 6=high) of Heavily indebted poor countries in 2006 to that in 2013?
Keep it short and to the point. 0.93. What is the ratio of the Rating (1=low 6=high) of Middle income in 2006 to that in 2013?
Offer a terse response. 0.95. What is the ratio of the Rating (1=low 6=high) of Heavily indebted poor countries in 2007 to that in 2008?
Provide a short and direct response. 0.99. What is the ratio of the Rating (1=low 6=high) of Middle income in 2007 to that in 2008?
Your response must be concise. 0.99. What is the ratio of the Rating (1=low 6=high) of Eritrea in 2007 to that in 2008?
Make the answer very short. 1. What is the ratio of the Rating (1=low 6=high) of Heavily indebted poor countries in 2007 to that in 2009?
Offer a very short reply. 0.99. What is the ratio of the Rating (1=low 6=high) of Heavily indebted poor countries in 2007 to that in 2010?
Your answer should be compact. 0.98. What is the ratio of the Rating (1=low 6=high) in Eritrea in 2007 to that in 2010?
Ensure brevity in your answer.  1. What is the ratio of the Rating (1=low 6=high) of Heavily indebted poor countries in 2007 to that in 2011?
Offer a terse response. 0.96. What is the ratio of the Rating (1=low 6=high) in Middle income in 2007 to that in 2011?
Provide a short and direct response. 0.97. What is the ratio of the Rating (1=low 6=high) of Eritrea in 2007 to that in 2011?
Offer a terse response. 1. What is the ratio of the Rating (1=low 6=high) of Heavily indebted poor countries in 2007 to that in 2012?
Provide a short and direct response. 0.95. What is the ratio of the Rating (1=low 6=high) of Middle income in 2007 to that in 2012?
Your response must be concise. 0.96. What is the ratio of the Rating (1=low 6=high) of Burundi in 2007 to that in 2012?
Your answer should be very brief. 0.75. What is the ratio of the Rating (1=low 6=high) in Heavily indebted poor countries in 2007 to that in 2013?
Give a very brief answer. 0.94. What is the ratio of the Rating (1=low 6=high) in Middle income in 2007 to that in 2013?
Offer a terse response. 0.96. What is the ratio of the Rating (1=low 6=high) of Burundi in 2007 to that in 2013?
Your response must be concise. 0.75. What is the ratio of the Rating (1=low 6=high) in Eritrea in 2007 to that in 2013?
Provide a succinct answer. 1. What is the ratio of the Rating (1=low 6=high) in Heavily indebted poor countries in 2008 to that in 2009?
Your answer should be very brief. 1. What is the ratio of the Rating (1=low 6=high) in Eritrea in 2008 to that in 2009?
Offer a very short reply. 1. What is the ratio of the Rating (1=low 6=high) in Heavily indebted poor countries in 2008 to that in 2010?
Provide a short and direct response. 0.99. What is the ratio of the Rating (1=low 6=high) in Middle income in 2008 to that in 2010?
Keep it short and to the point. 1. What is the ratio of the Rating (1=low 6=high) in Heavily indebted poor countries in 2008 to that in 2011?
Ensure brevity in your answer.  0.97. What is the ratio of the Rating (1=low 6=high) of Burundi in 2008 to that in 2011?
Ensure brevity in your answer.  0.86. What is the ratio of the Rating (1=low 6=high) in Heavily indebted poor countries in 2008 to that in 2012?
Provide a short and direct response. 0.95. What is the ratio of the Rating (1=low 6=high) in Middle income in 2008 to that in 2012?
Provide a short and direct response. 0.97. What is the ratio of the Rating (1=low 6=high) in Eritrea in 2008 to that in 2012?
Offer a very short reply. 1. What is the ratio of the Rating (1=low 6=high) in Heavily indebted poor countries in 2008 to that in 2013?
Ensure brevity in your answer.  0.95. What is the ratio of the Rating (1=low 6=high) of Middle income in 2008 to that in 2013?
Provide a short and direct response. 0.97. What is the ratio of the Rating (1=low 6=high) in Burundi in 2008 to that in 2013?
Your response must be concise. 0.75. What is the ratio of the Rating (1=low 6=high) in Heavily indebted poor countries in 2009 to that in 2010?
Provide a succinct answer. 0.99. What is the ratio of the Rating (1=low 6=high) of Middle income in 2009 to that in 2010?
Provide a succinct answer. 0.99. What is the ratio of the Rating (1=low 6=high) of Burundi in 2009 to that in 2010?
Your answer should be very brief. 0.86. What is the ratio of the Rating (1=low 6=high) in Eritrea in 2009 to that in 2010?
Give a very brief answer. 1. What is the ratio of the Rating (1=low 6=high) of Heavily indebted poor countries in 2009 to that in 2011?
Ensure brevity in your answer.  0.97. What is the ratio of the Rating (1=low 6=high) in Middle income in 2009 to that in 2011?
Provide a short and direct response. 0.98. What is the ratio of the Rating (1=low 6=high) of Burundi in 2009 to that in 2011?
Your answer should be compact. 0.86. What is the ratio of the Rating (1=low 6=high) of Heavily indebted poor countries in 2009 to that in 2012?
Make the answer very short. 0.95. What is the ratio of the Rating (1=low 6=high) in Middle income in 2009 to that in 2012?
Offer a terse response. 0.96. What is the ratio of the Rating (1=low 6=high) of Eritrea in 2009 to that in 2012?
Provide a short and direct response. 1. What is the ratio of the Rating (1=low 6=high) in Heavily indebted poor countries in 2009 to that in 2013?
Make the answer very short. 0.94. What is the ratio of the Rating (1=low 6=high) of Middle income in 2009 to that in 2013?
Provide a succinct answer. 0.96. What is the ratio of the Rating (1=low 6=high) in Eritrea in 2009 to that in 2013?
Offer a terse response. 1. What is the ratio of the Rating (1=low 6=high) of Heavily indebted poor countries in 2010 to that in 2011?
Offer a very short reply. 0.98. What is the ratio of the Rating (1=low 6=high) in Middle income in 2010 to that in 2011?
Provide a succinct answer. 0.99. What is the ratio of the Rating (1=low 6=high) of Burundi in 2010 to that in 2011?
Your answer should be very brief. 1. What is the ratio of the Rating (1=low 6=high) in Heavily indebted poor countries in 2010 to that in 2012?
Give a very brief answer. 0.96. What is the ratio of the Rating (1=low 6=high) in Middle income in 2010 to that in 2012?
Offer a very short reply. 0.98. What is the ratio of the Rating (1=low 6=high) in Burundi in 2010 to that in 2012?
Ensure brevity in your answer.  0.88. What is the ratio of the Rating (1=low 6=high) in Eritrea in 2010 to that in 2012?
Offer a terse response. 1. What is the ratio of the Rating (1=low 6=high) in Heavily indebted poor countries in 2010 to that in 2013?
Your answer should be compact. 0.96. What is the ratio of the Rating (1=low 6=high) of Middle income in 2010 to that in 2013?
Your answer should be compact. 0.97. What is the ratio of the Rating (1=low 6=high) in Burundi in 2010 to that in 2013?
Keep it short and to the point. 0.88. What is the ratio of the Rating (1=low 6=high) in Heavily indebted poor countries in 2011 to that in 2012?
Make the answer very short. 0.98. What is the ratio of the Rating (1=low 6=high) of Middle income in 2011 to that in 2012?
Ensure brevity in your answer.  0.99. What is the ratio of the Rating (1=low 6=high) in Burundi in 2011 to that in 2012?
Offer a very short reply. 0.88. What is the ratio of the Rating (1=low 6=high) of Eritrea in 2011 to that in 2012?
Give a very brief answer. 1. What is the ratio of the Rating (1=low 6=high) in Heavily indebted poor countries in 2011 to that in 2013?
Provide a short and direct response. 0.98. What is the ratio of the Rating (1=low 6=high) in Burundi in 2011 to that in 2013?
Offer a very short reply. 0.88. What is the ratio of the Rating (1=low 6=high) in Eritrea in 2011 to that in 2013?
Make the answer very short. 1. What is the ratio of the Rating (1=low 6=high) in Middle income in 2012 to that in 2013?
Ensure brevity in your answer.  1. What is the ratio of the Rating (1=low 6=high) in Burundi in 2012 to that in 2013?
Provide a short and direct response. 1. What is the ratio of the Rating (1=low 6=high) of Eritrea in 2012 to that in 2013?
Your response must be concise. 1. What is the difference between the highest and the second highest Rating (1=low 6=high) in Heavily indebted poor countries?
Your answer should be very brief. 0.03. What is the difference between the highest and the second highest Rating (1=low 6=high) in Middle income?
Provide a succinct answer. 0.02. What is the difference between the highest and the lowest Rating (1=low 6=high) of Heavily indebted poor countries?
Provide a short and direct response. 0.26. What is the difference between the highest and the lowest Rating (1=low 6=high) in Middle income?
Offer a terse response. 0.2. What is the difference between the highest and the lowest Rating (1=low 6=high) in Burundi?
Provide a succinct answer. 1. What is the difference between the highest and the lowest Rating (1=low 6=high) of Eritrea?
Your answer should be compact. 0. 